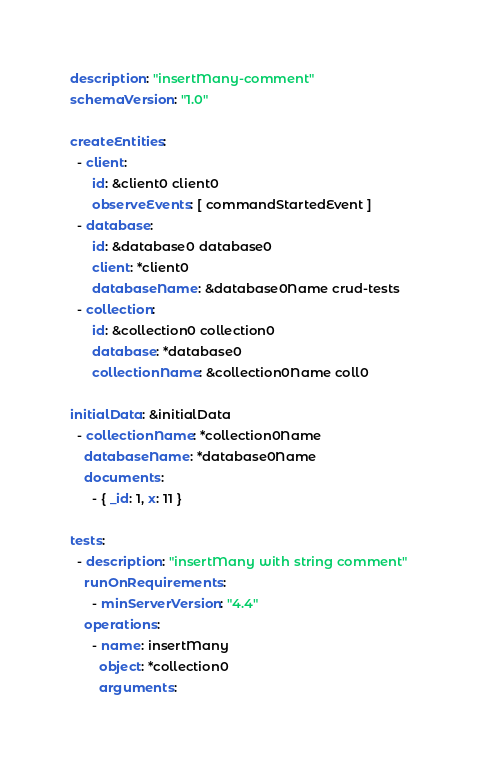Convert code to text. <code><loc_0><loc_0><loc_500><loc_500><_YAML_>description: "insertMany-comment"
schemaVersion: "1.0"

createEntities:
  - client:
      id: &client0 client0
      observeEvents: [ commandStartedEvent ]
  - database:
      id: &database0 database0
      client: *client0
      databaseName: &database0Name crud-tests
  - collection:
      id: &collection0 collection0
      database: *database0
      collectionName: &collection0Name coll0

initialData: &initialData
  - collectionName: *collection0Name
    databaseName: *database0Name
    documents:
      - { _id: 1, x: 11 }

tests:
  - description: "insertMany with string comment"
    runOnRequirements:
      - minServerVersion: "4.4"
    operations:
      - name: insertMany
        object: *collection0
        arguments:</code> 